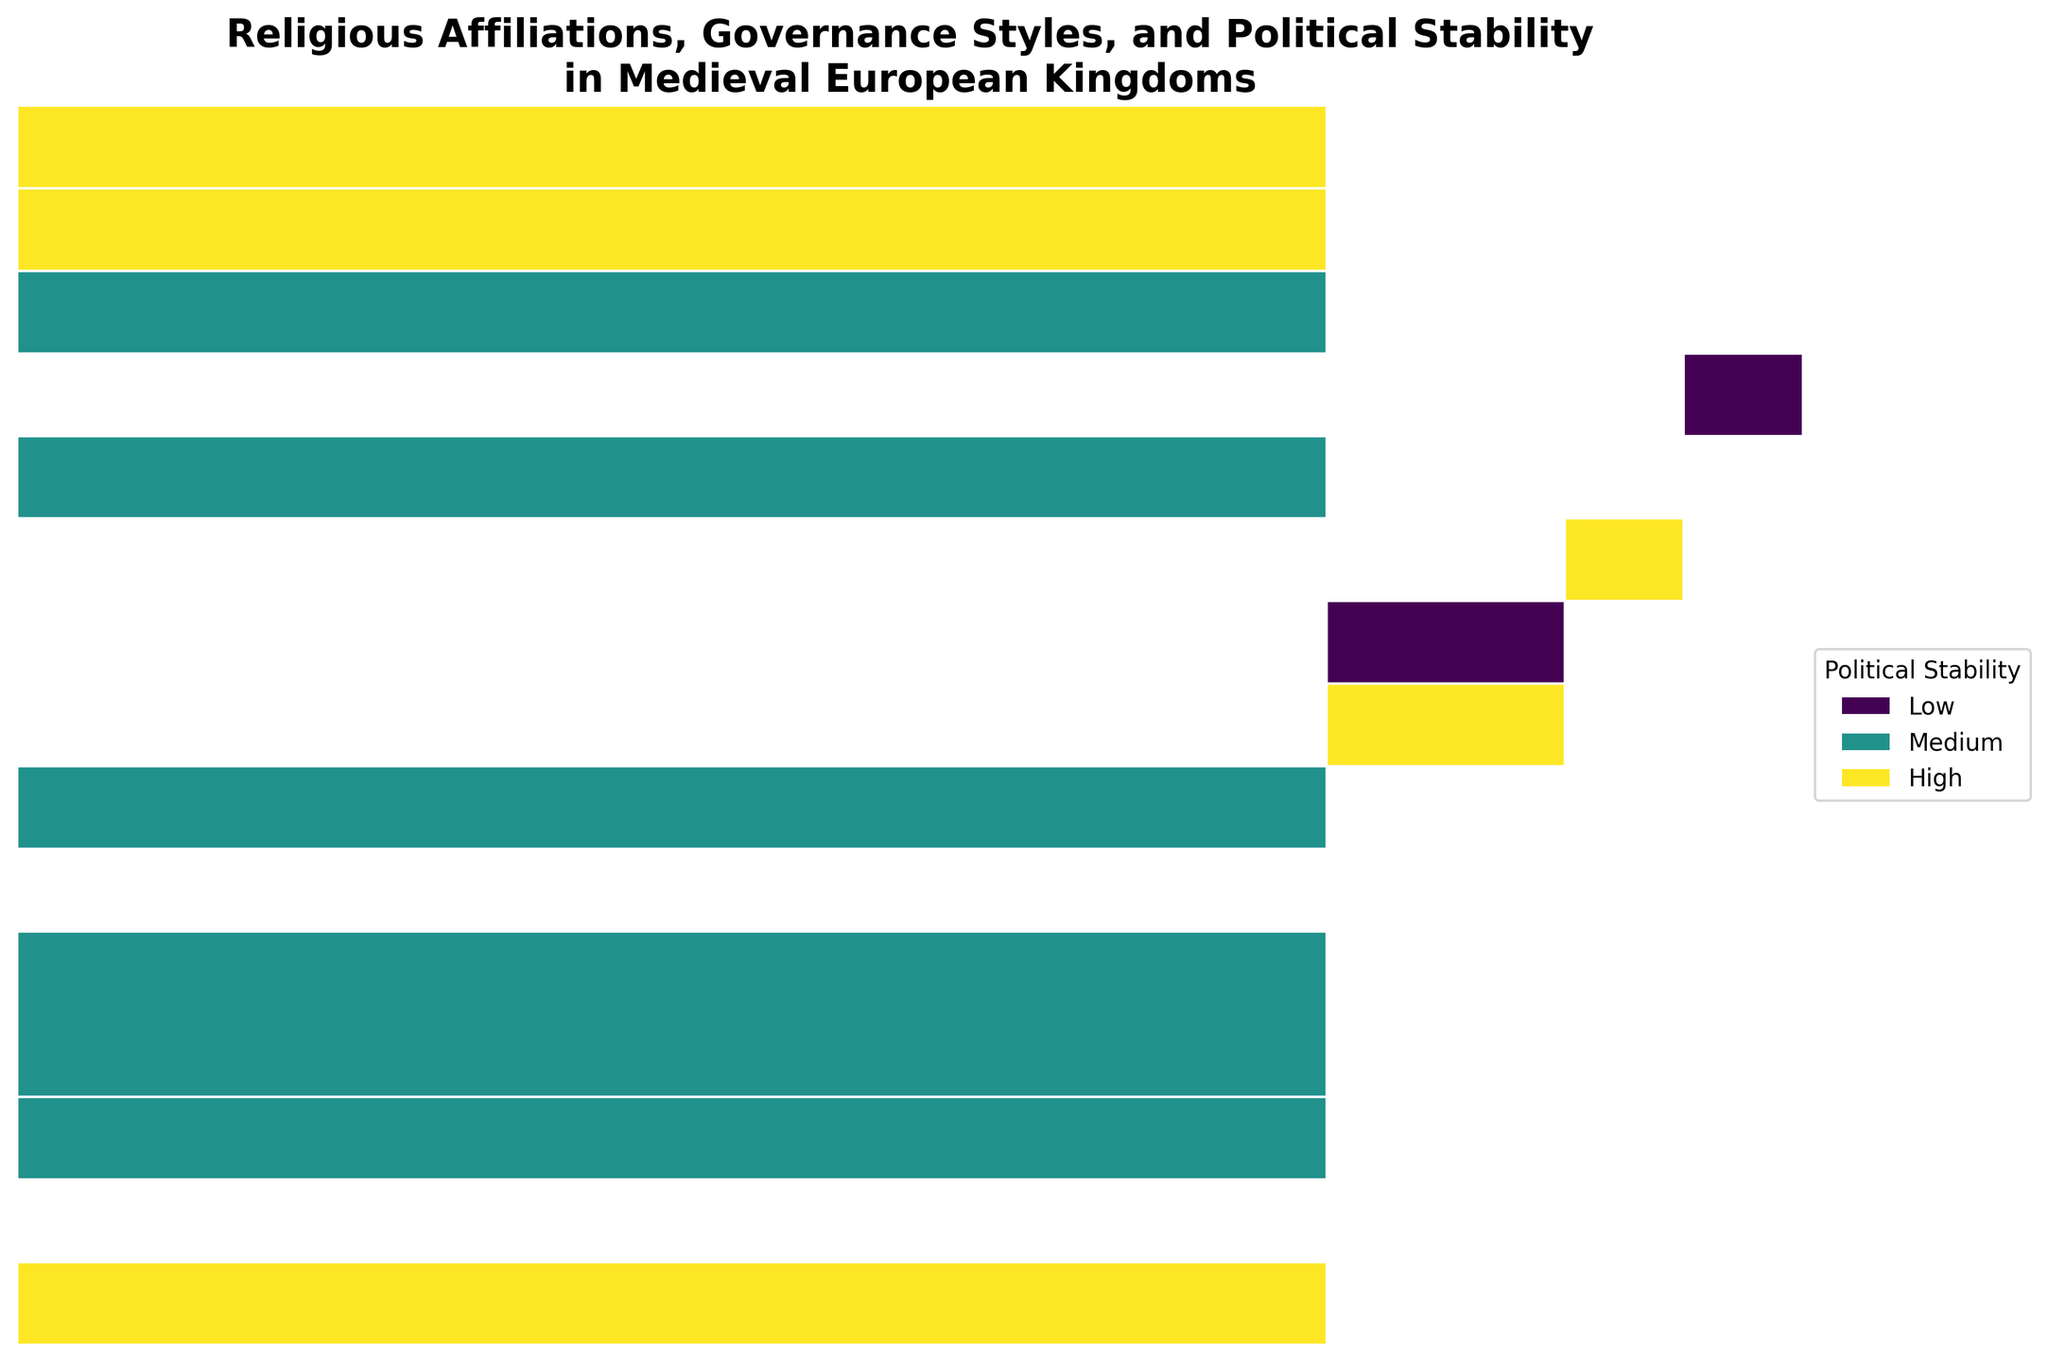How many governance styles are present in the mosaic plot? The governance styles are indicated on the y-axis labels. Each distinct label represents a different governance style.
Answer: 10 Which religion has the most diversity in governance styles? To determine this, count the number of unique governance styles across each religion's section. The religion with the most sections across different governance styles has the most diversity.
Answer: Catholic How does political stability vary for kingdoms with the Centralized governance style? Identify the sections corresponding to the Centralized governance style on the y-axis. Then, observe the variation in colors which correspond to the different levels of political stability.
Answer: Medium (France) Which political stability level appears most frequently for kingdoms with a Feudal governance style? Find the segments corresponding to Feudal governance on the y-axis. The color with the largest area within these segments represents the most frequent political stability level for Feudal governance.
Answer: High For which governance style is political stability categorized as High most of the time? Look for the governance style sections that contain a majority of dark green (indicating high stability) within their segments.
Answer: Feudal Which governance style associated with the Orthodox religion appears to have lower political stability? Identify the sections belonging to the Orthodox religion and examine their corresponding governance styles. Compare these styles for the color associated with low political stability.
Answer: Principality In general, how does the political stability of kingdoms governed by Theocracy compare to those governed by Oligarchy? Locate the segments for Theocracy and Oligarchy on the y-axis. Compare the distribution of colors in these sections, specifically looking for the prevalence of high (dark green), medium (yellow-green), and low (light green) stability.
Answer: Theocracy generally has high stability, while Oligarchy also shows high stability How does the political stability distribution of kingdoms under Elective Monarchy governance compare to those under Noble Democracy? Find the segments for Elective Monarchy and Noble Democracy on the y-axis and compare the color distribution within each governance style, noting the frequencies of low, medium, and high stability.
Answer: Elective Monarchy has low to medium stability, while Noble Democracy has medium stability Which governance style within the Catholic religion tends to have higher political stability: Elective Monarchy or Apostolic Kingdom? Identify the segments for Catholic religion. Within those, compare the areas that correspond to Elective Monarchy and Apostolic Kingdom side by side, focusing on the colors representing high stability.
Answer: Apostolic Kingdom Which religion tends to have the highest proportion of kingdoms with high political stability? For each religion, find the segments with a higher proportion of dark green. The religion with a larger dark green area relative to its total area can be considered to have a higher proportion of high political stability.
Answer: Catholic 